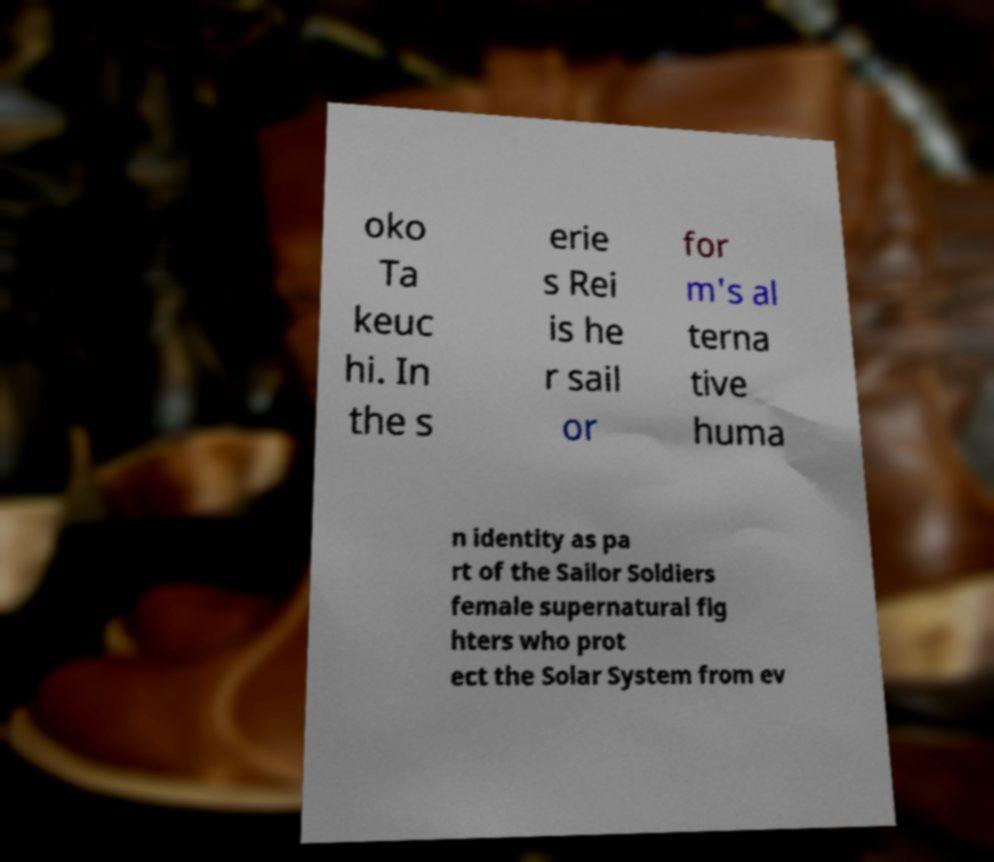Can you accurately transcribe the text from the provided image for me? oko Ta keuc hi. In the s erie s Rei is he r sail or for m's al terna tive huma n identity as pa rt of the Sailor Soldiers female supernatural fig hters who prot ect the Solar System from ev 